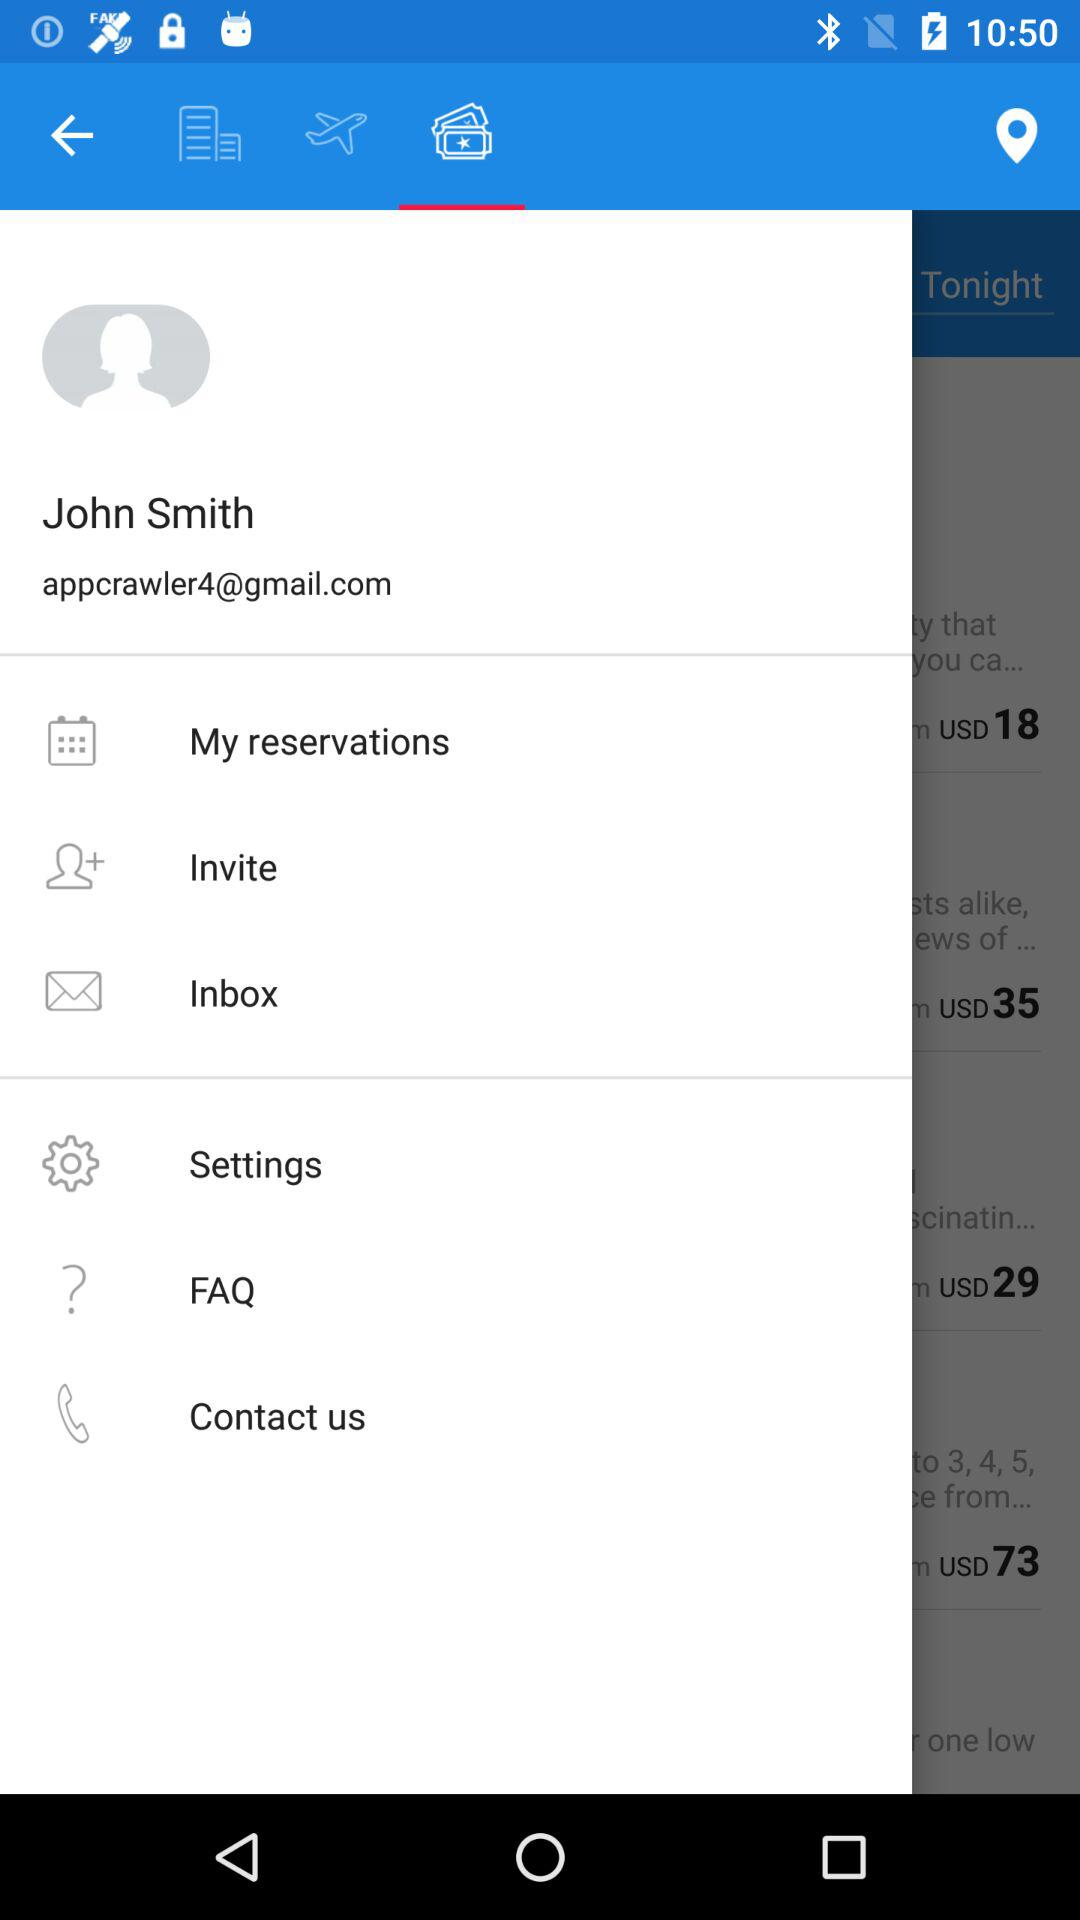What is the email address? The email address is appcrawler4@gmail.com. 